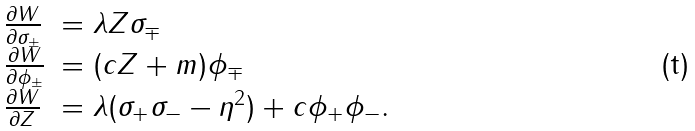<formula> <loc_0><loc_0><loc_500><loc_500>\begin{array} { l l } \frac { \partial W } { \partial \sigma _ { \pm } } & = \lambda Z \sigma _ { \mp } \\ \frac { \partial W } { \partial \phi _ { \pm } } & = ( c Z + m ) \phi _ { \mp } \\ \frac { \partial W } { \partial Z } & = \lambda ( \sigma _ { + } \sigma _ { - } - \eta ^ { 2 } ) + c \phi _ { + } \phi _ { - } . \end{array}</formula> 